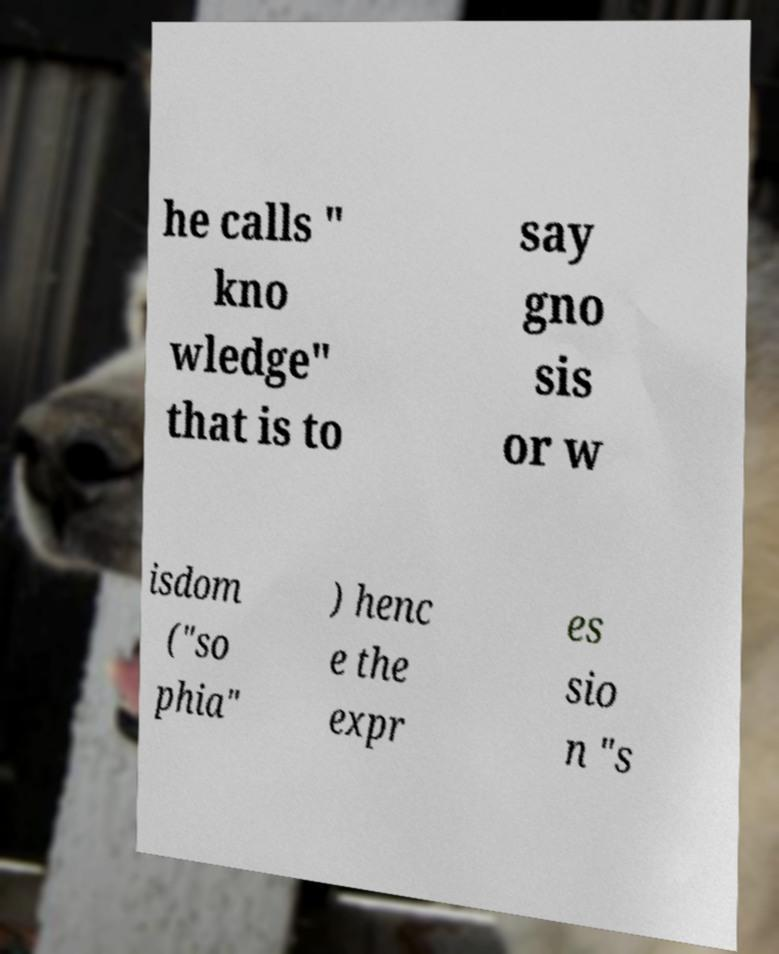Please read and relay the text visible in this image. What does it say? he calls " kno wledge" that is to say gno sis or w isdom ("so phia" ) henc e the expr es sio n "s 